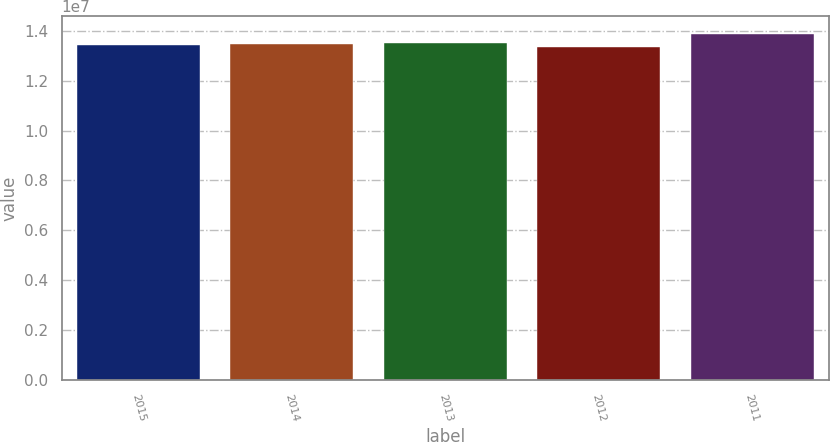<chart> <loc_0><loc_0><loc_500><loc_500><bar_chart><fcel>2015<fcel>2014<fcel>2013<fcel>2012<fcel>2011<nl><fcel>1.3429e+07<fcel>1.34831e+07<fcel>1.35372e+07<fcel>1.336e+07<fcel>1.3901e+07<nl></chart> 